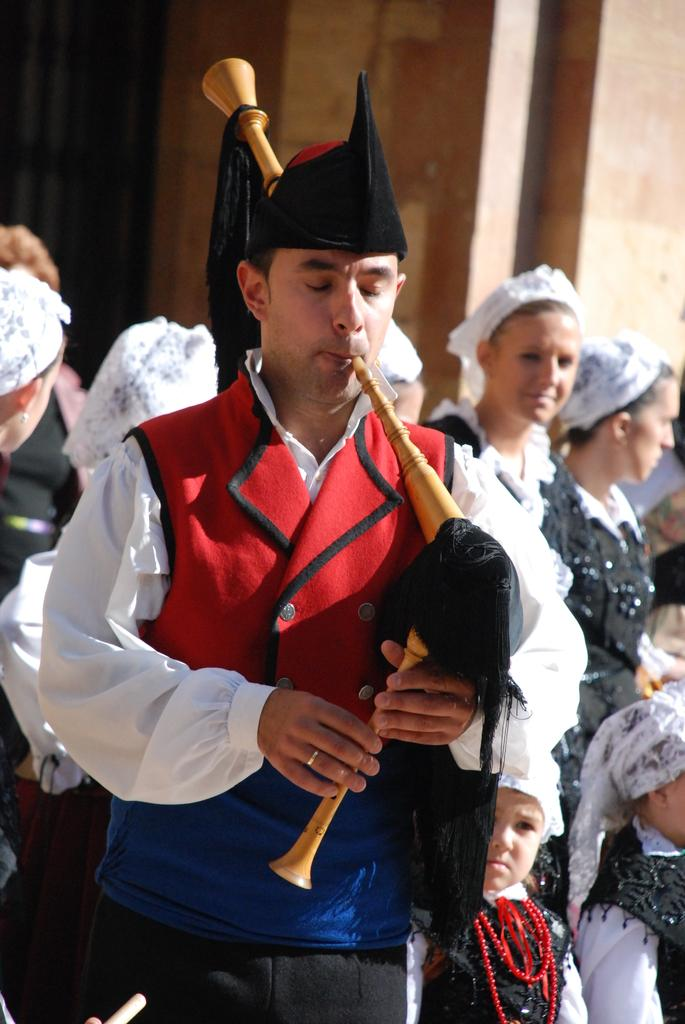How many people are in the image? There is a group of people in the image. What is the man in the image doing? A man is playing a musical instrument in the image. What can be seen in the background of the image? There is a wall in the background of the image. What type of body is visible in the image? There is no body present in the image; it features a group of people and a man playing a musical instrument. Can you tell me how the bedroom looks in the image? There is no bedroom present in the image. 